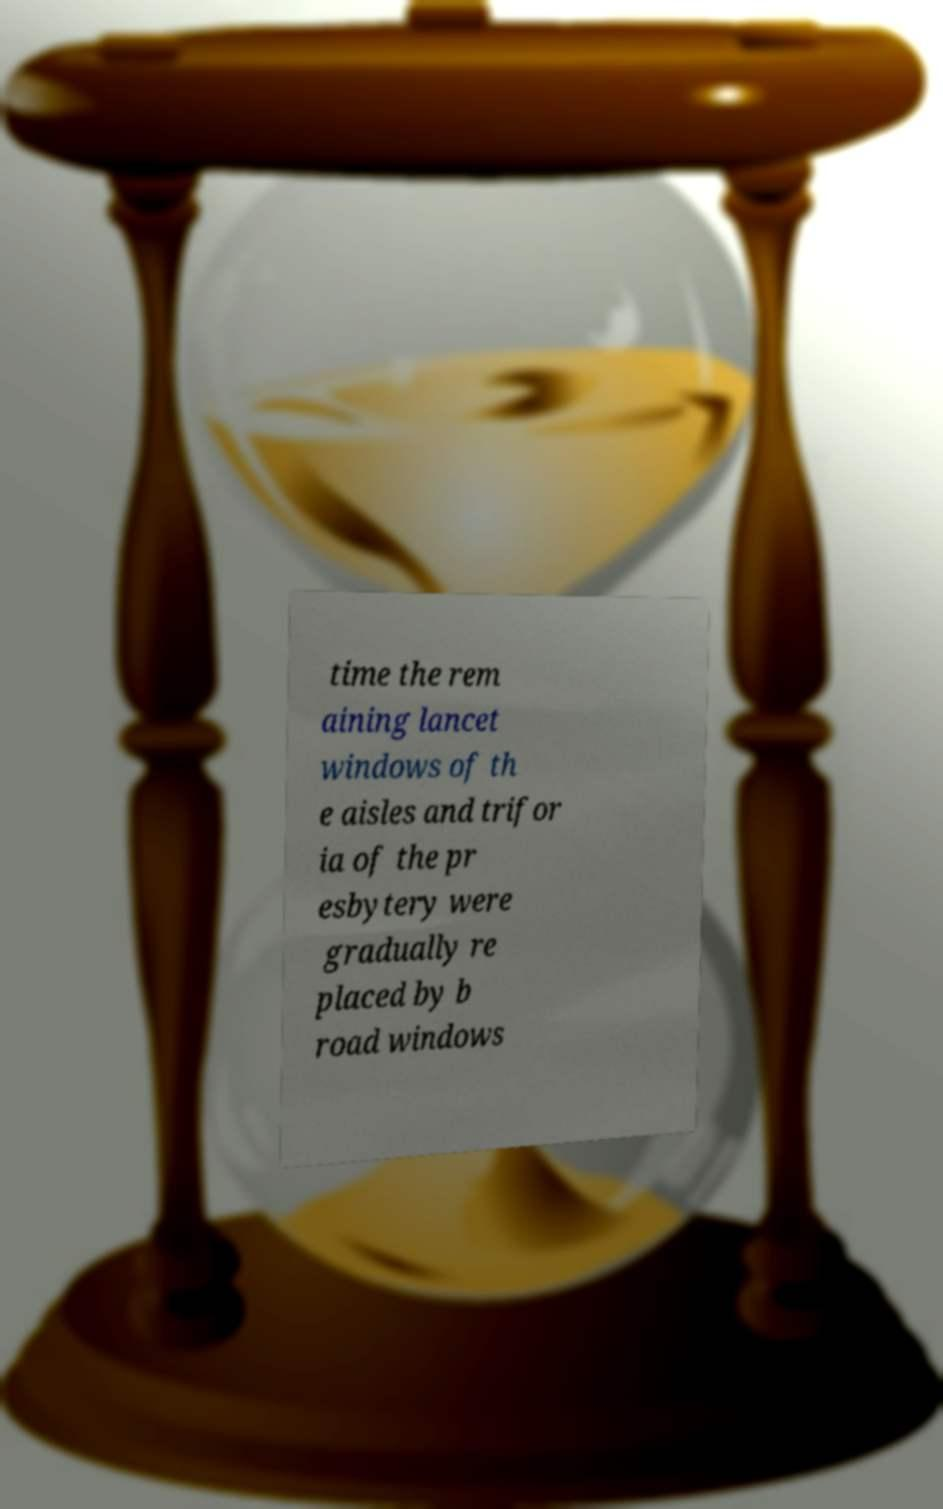I need the written content from this picture converted into text. Can you do that? time the rem aining lancet windows of th e aisles and trifor ia of the pr esbytery were gradually re placed by b road windows 